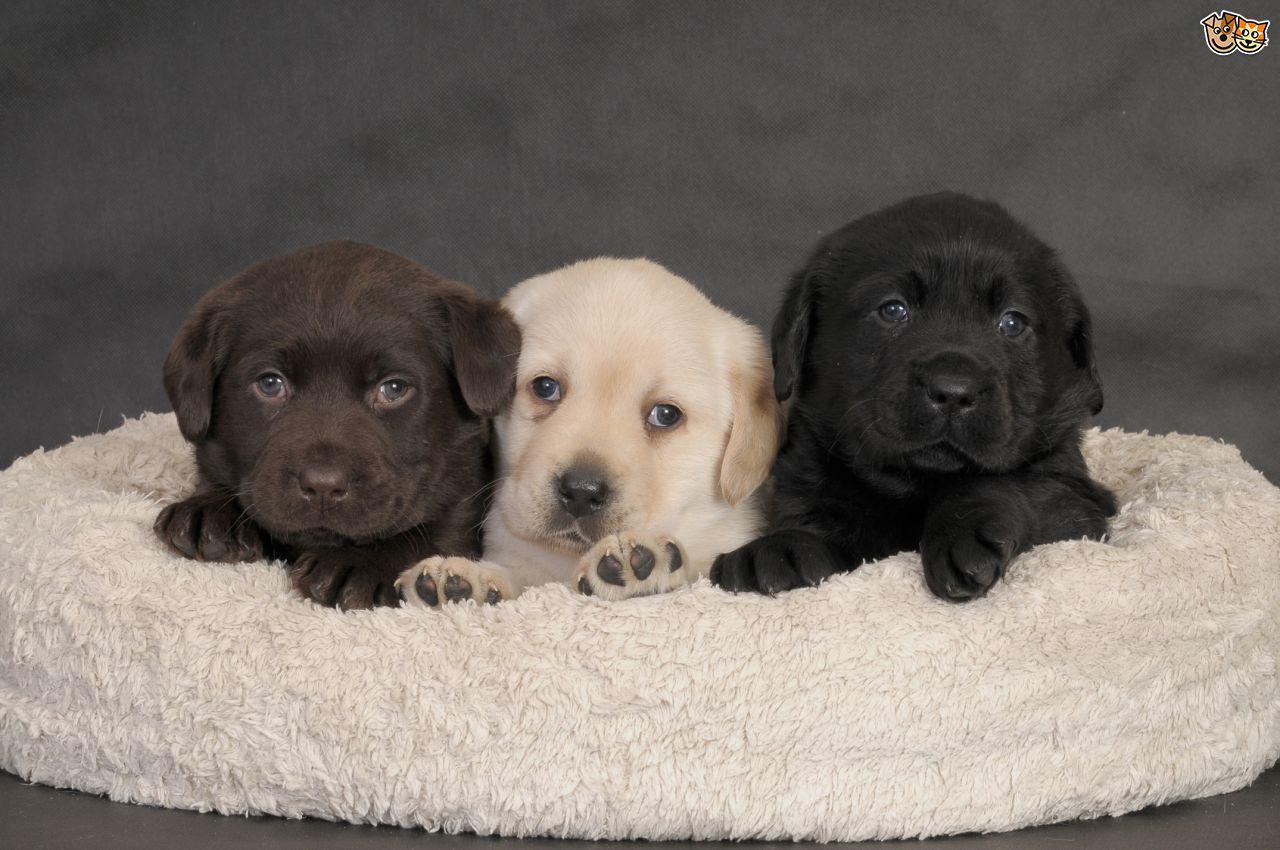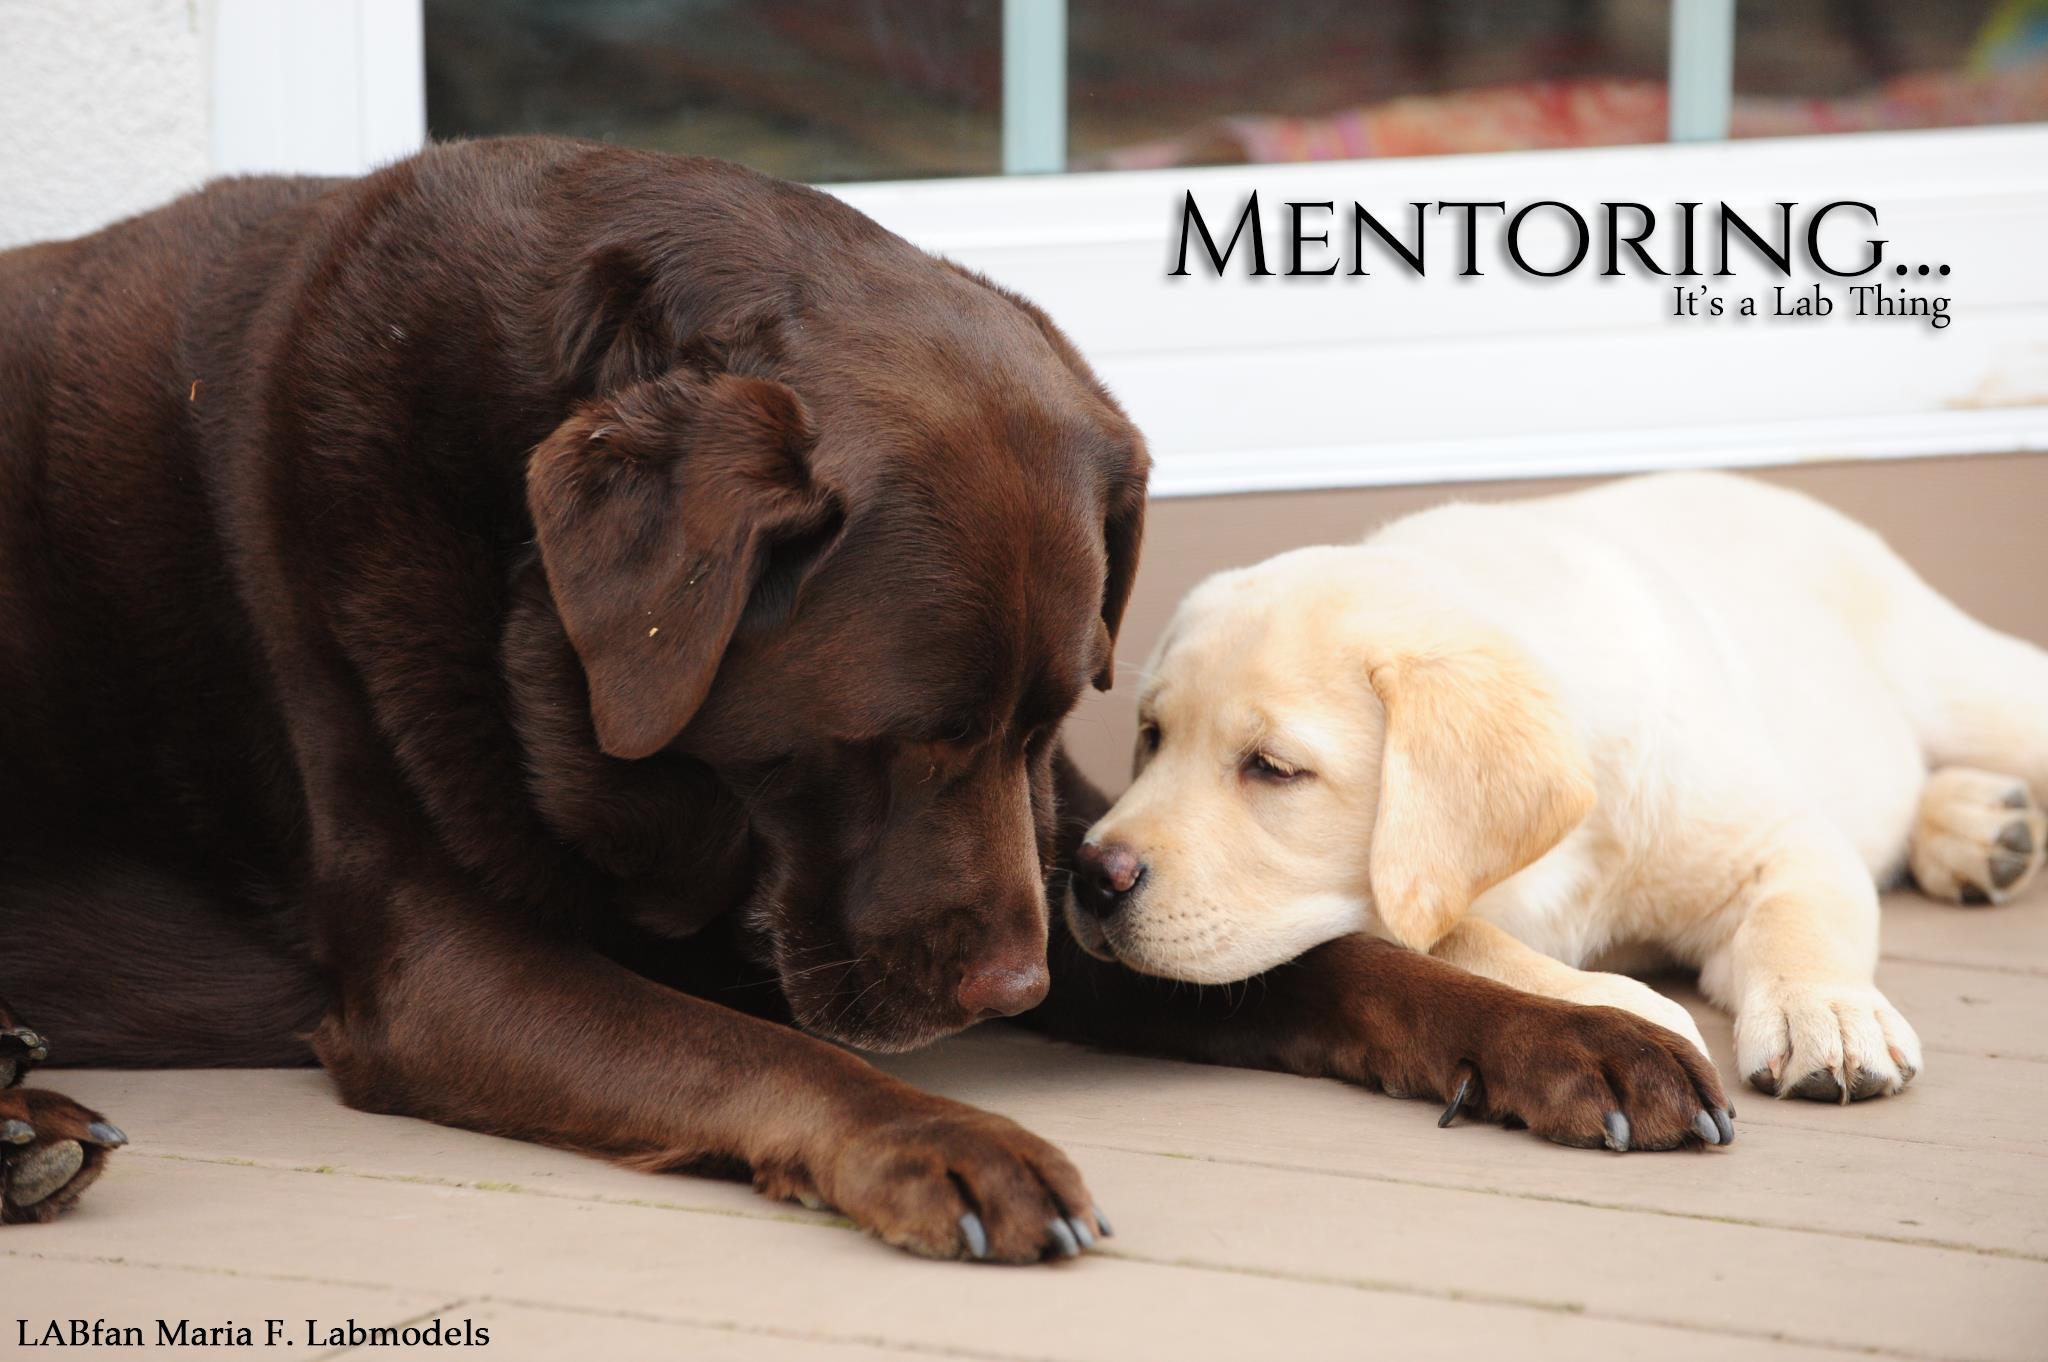The first image is the image on the left, the second image is the image on the right. For the images shown, is this caption "There are three dogs in one picture and two in the other picture." true? Answer yes or no. Yes. The first image is the image on the left, the second image is the image on the right. Given the left and right images, does the statement "There are a total of 2 adult Labradors interacting with each other." hold true? Answer yes or no. No. 